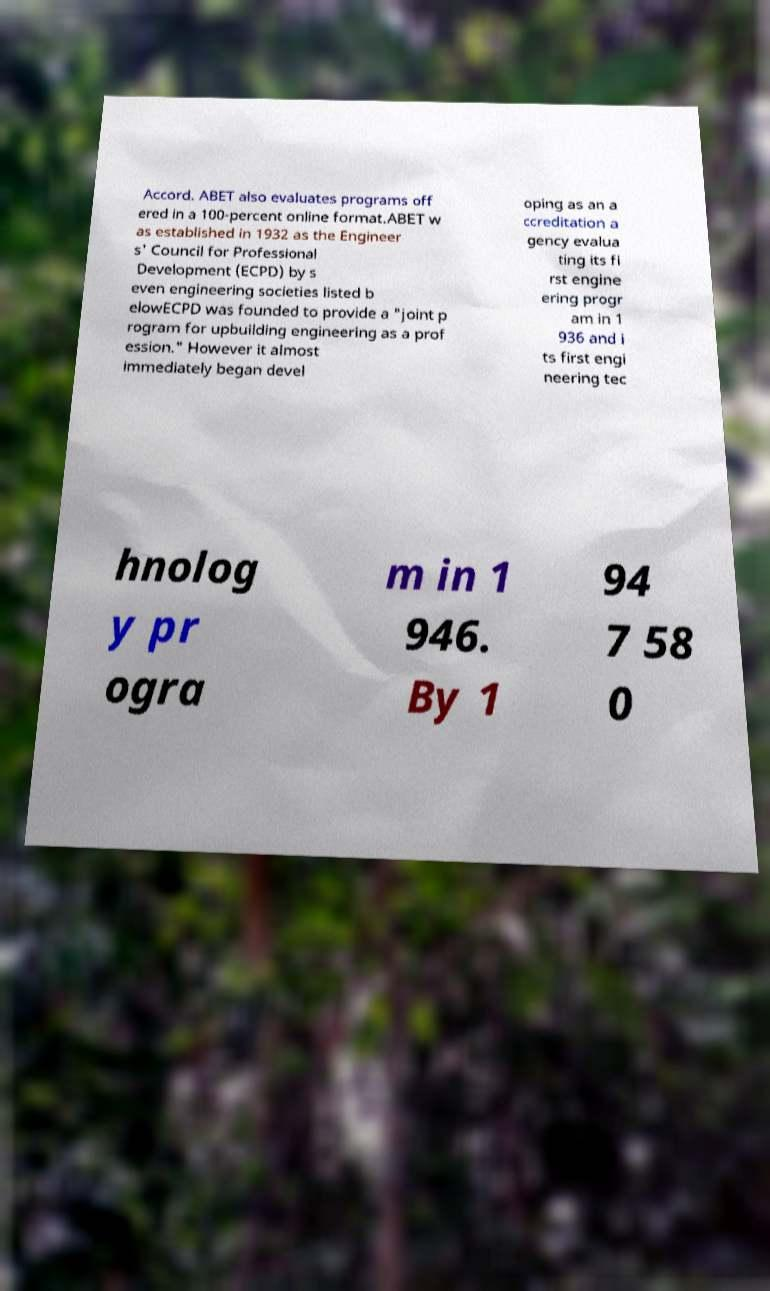Could you assist in decoding the text presented in this image and type it out clearly? Accord. ABET also evaluates programs off ered in a 100-percent online format.ABET w as established in 1932 as the Engineer s' Council for Professional Development (ECPD) by s even engineering societies listed b elowECPD was founded to provide a "joint p rogram for upbuilding engineering as a prof ession." However it almost immediately began devel oping as an a ccreditation a gency evalua ting its fi rst engine ering progr am in 1 936 and i ts first engi neering tec hnolog y pr ogra m in 1 946. By 1 94 7 58 0 